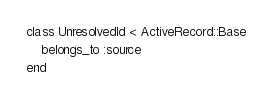Convert code to text. <code><loc_0><loc_0><loc_500><loc_500><_Ruby_>class UnresolvedId < ActiveRecord::Base
	belongs_to :source
end
</code> 